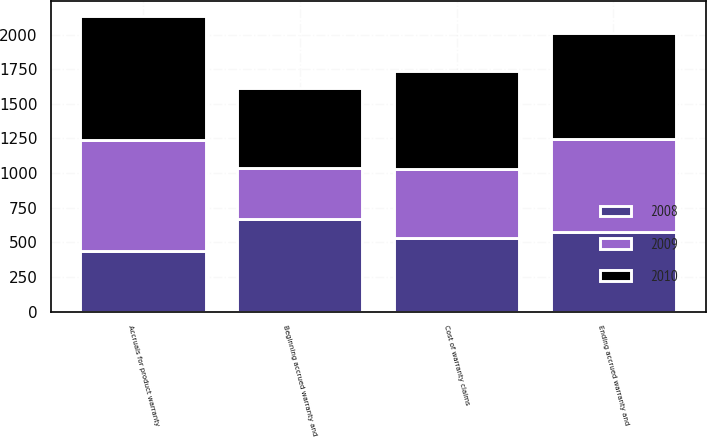Convert chart. <chart><loc_0><loc_0><loc_500><loc_500><stacked_bar_chart><ecel><fcel>Beginning accrued warranty and<fcel>Cost of warranty claims<fcel>Accruals for product warranty<fcel>Ending accrued warranty and<nl><fcel>2010<fcel>577<fcel>713<fcel>897<fcel>761<nl><fcel>2008<fcel>671<fcel>534<fcel>440<fcel>577<nl><fcel>2009<fcel>363<fcel>493<fcel>801<fcel>671<nl></chart> 